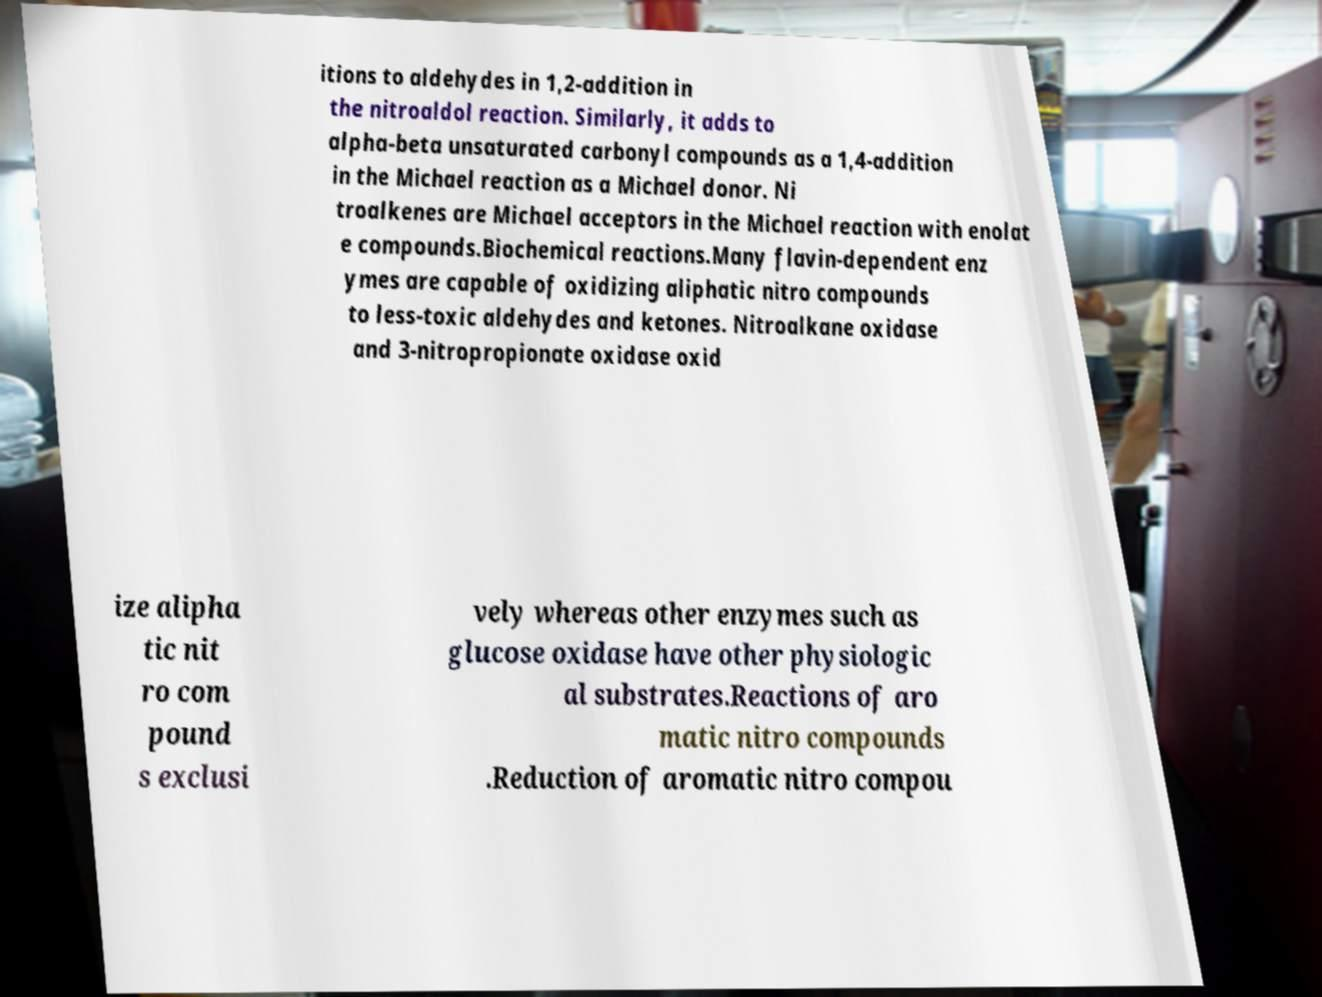Please read and relay the text visible in this image. What does it say? itions to aldehydes in 1,2-addition in the nitroaldol reaction. Similarly, it adds to alpha-beta unsaturated carbonyl compounds as a 1,4-addition in the Michael reaction as a Michael donor. Ni troalkenes are Michael acceptors in the Michael reaction with enolat e compounds.Biochemical reactions.Many flavin-dependent enz ymes are capable of oxidizing aliphatic nitro compounds to less-toxic aldehydes and ketones. Nitroalkane oxidase and 3-nitropropionate oxidase oxid ize alipha tic nit ro com pound s exclusi vely whereas other enzymes such as glucose oxidase have other physiologic al substrates.Reactions of aro matic nitro compounds .Reduction of aromatic nitro compou 